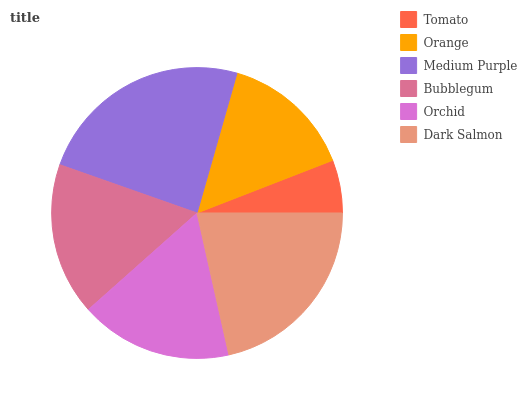Is Tomato the minimum?
Answer yes or no. Yes. Is Medium Purple the maximum?
Answer yes or no. Yes. Is Orange the minimum?
Answer yes or no. No. Is Orange the maximum?
Answer yes or no. No. Is Orange greater than Tomato?
Answer yes or no. Yes. Is Tomato less than Orange?
Answer yes or no. Yes. Is Tomato greater than Orange?
Answer yes or no. No. Is Orange less than Tomato?
Answer yes or no. No. Is Orchid the high median?
Answer yes or no. Yes. Is Bubblegum the low median?
Answer yes or no. Yes. Is Tomato the high median?
Answer yes or no. No. Is Dark Salmon the low median?
Answer yes or no. No. 